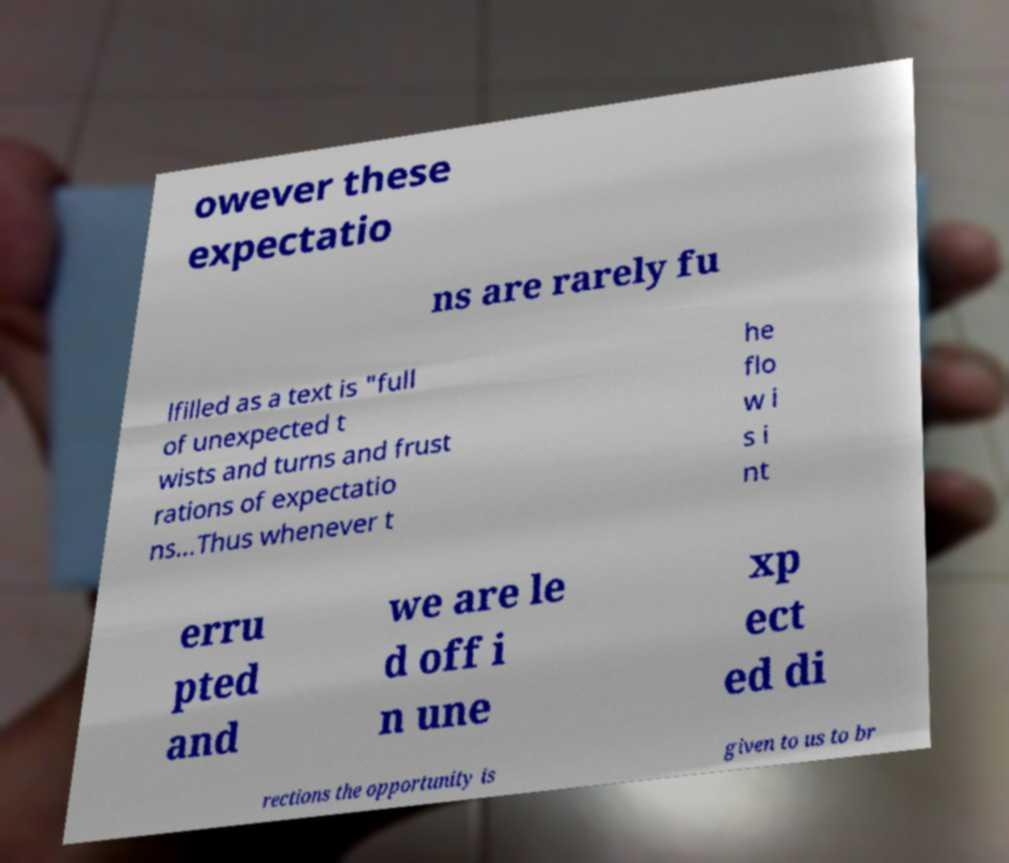Please read and relay the text visible in this image. What does it say? owever these expectatio ns are rarely fu lfilled as a text is "full of unexpected t wists and turns and frust rations of expectatio ns…Thus whenever t he flo w i s i nt erru pted and we are le d off i n une xp ect ed di rections the opportunity is given to us to br 